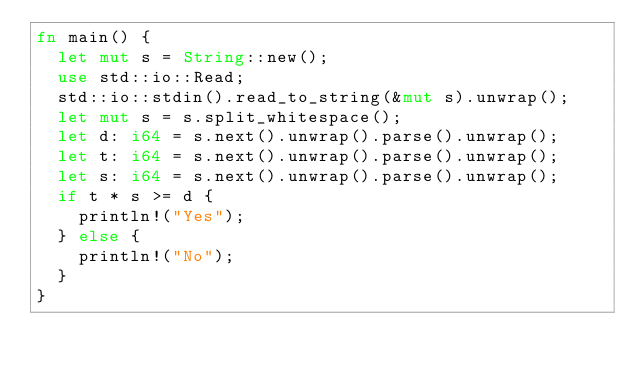<code> <loc_0><loc_0><loc_500><loc_500><_Rust_>fn main() {
	let mut s = String::new();
	use std::io::Read;
	std::io::stdin().read_to_string(&mut s).unwrap();
	let mut s = s.split_whitespace();
	let d: i64 = s.next().unwrap().parse().unwrap();
	let t: i64 = s.next().unwrap().parse().unwrap();
	let s: i64 = s.next().unwrap().parse().unwrap();
	if t * s >= d {
		println!("Yes");
	} else {
		println!("No");
	}
}
</code> 